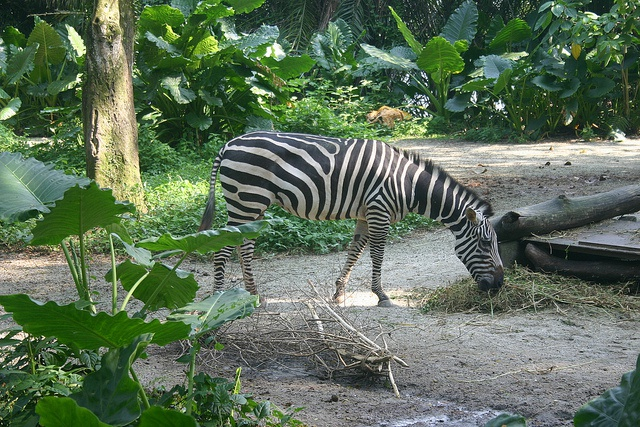Describe the objects in this image and their specific colors. I can see a zebra in black, gray, darkgray, and lightgray tones in this image. 